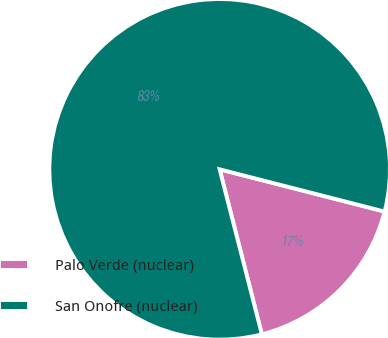Convert chart. <chart><loc_0><loc_0><loc_500><loc_500><pie_chart><fcel>Palo Verde (nuclear)<fcel>San Onofre (nuclear)<nl><fcel>17.02%<fcel>82.98%<nl></chart> 